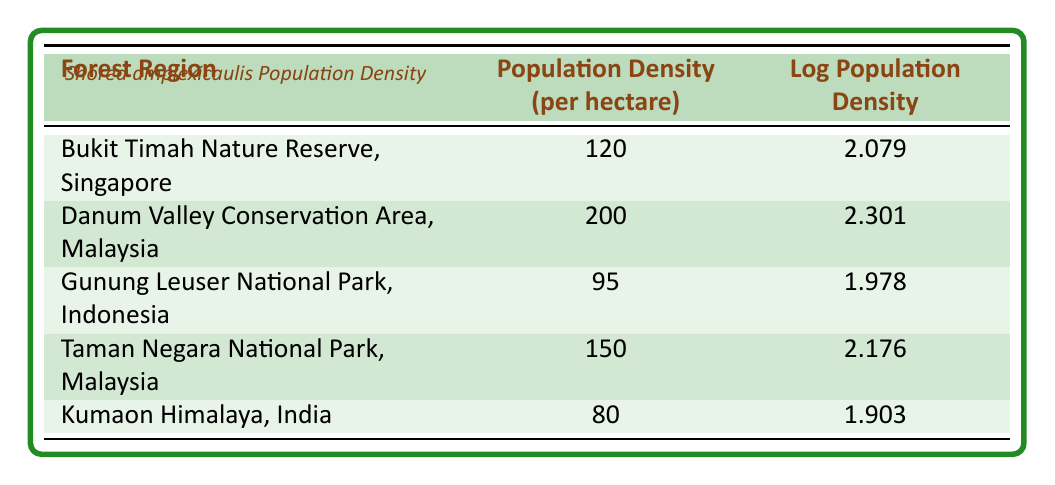What is the population density of Shorea amplexicaulis in Danum Valley Conservation Area, Malaysia? According to the table, the population density per hectare in Danum Valley Conservation Area is given directly as 200.
Answer: 200 Which forest region has the lowest population density for Shorea amplexicaulis? By comparing the values in the population density column, Kumaon Himalaya, India at 80 has the lowest population density.
Answer: Kumaon Himalaya, India What is the average population density across all listed forest regions? To find the average, add the values: 120 + 200 + 95 + 150 + 80 = 645. There are 5 regions, so the average is 645/5 = 129.
Answer: 129 Is the log population density of Shorea amplexicaulis highest in Taman Negara National Park, Malaysia? The log population density in Taman Negara is 2.176; comparing with others: Bukit Timah has 2.079, Danum Valley 2.301, Gunung Leuser 1.978, and Kumaon Himalaya 1.903. Since 2.301 (Danum Valley) is higher than 2.176, the statement is false.
Answer: No What is the difference in population density between Danum Valley Conservation Area and Gunung Leuser National Park? The population density for Danum Valley is 200 and for Gunung Leuser it is 95. Subtracting these: 200 - 95 = 105 shows the difference.
Answer: 105 Which region has a log population density greater than 2? Evaluating the log population densities: Bukit Timah (2.079), Danum Valley (2.301), and Taman Negara (2.176) are all greater than 2, indicating multiple regions meet this criterion.
Answer: Bukit Timah, Danum Valley, Taman Negara What is the total of the log population densities for all regions? Adding the log values: 2.079 + 2.301 + 1.978 + 2.176 + 1.903 = 10.437 gives the total for the log population densities.
Answer: 10.437 Is the population density per hectare in Bukit Timah Nature Reserve greater than that in Kumaon Himalaya? Comparing values, Bukit Timah has 120 while Kumaon Himalaya has 80. Since 120 is greater than 80, the statement is true.
Answer: Yes Which forest region shows a population density that is less than the average? The average was calculated to be 129. Now looking at the regions, Kumaon Himalaya (80) and Gunung Leuser (95) are both less than this average.
Answer: Kumaon Himalaya, Gunung Leuser 